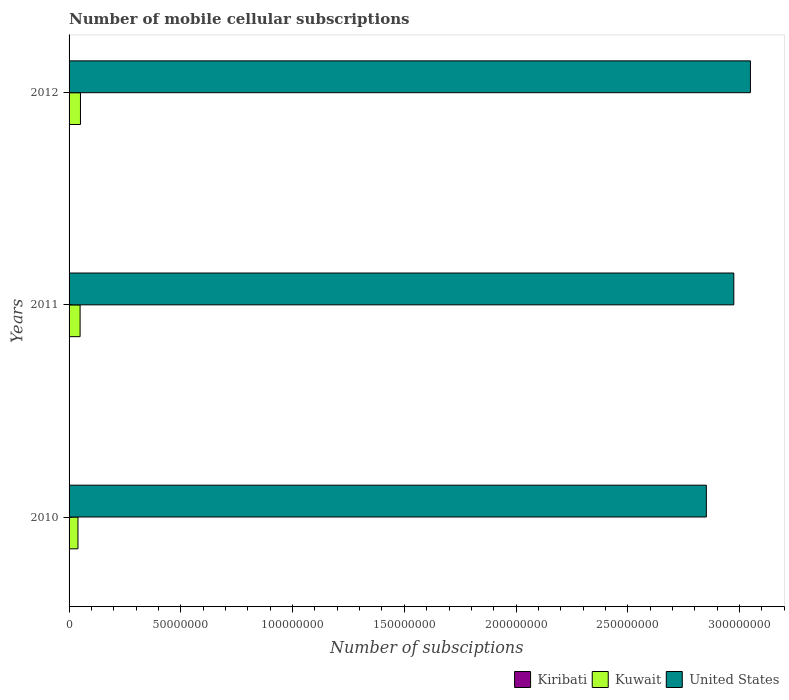How many different coloured bars are there?
Your answer should be compact. 3. How many groups of bars are there?
Your answer should be compact. 3. What is the label of the 3rd group of bars from the top?
Offer a terse response. 2010. What is the number of mobile cellular subscriptions in Kiribati in 2012?
Your answer should be very brief. 1.60e+04. Across all years, what is the maximum number of mobile cellular subscriptions in United States?
Offer a very short reply. 3.05e+08. Across all years, what is the minimum number of mobile cellular subscriptions in Kuwait?
Offer a very short reply. 3.98e+06. In which year was the number of mobile cellular subscriptions in Kuwait minimum?
Give a very brief answer. 2010. What is the total number of mobile cellular subscriptions in Kiribati in the graph?
Make the answer very short. 4.04e+04. What is the difference between the number of mobile cellular subscriptions in Kiribati in 2010 and that in 2012?
Keep it short and to the point. -5405. What is the difference between the number of mobile cellular subscriptions in United States in 2010 and the number of mobile cellular subscriptions in Kiribati in 2011?
Make the answer very short. 2.85e+08. What is the average number of mobile cellular subscriptions in United States per year?
Offer a terse response. 2.96e+08. In the year 2010, what is the difference between the number of mobile cellular subscriptions in Kuwait and number of mobile cellular subscriptions in United States?
Offer a terse response. -2.81e+08. In how many years, is the number of mobile cellular subscriptions in Kiribati greater than 110000000 ?
Provide a short and direct response. 0. What is the ratio of the number of mobile cellular subscriptions in United States in 2010 to that in 2011?
Keep it short and to the point. 0.96. Is the number of mobile cellular subscriptions in Kuwait in 2011 less than that in 2012?
Your answer should be compact. Yes. Is the difference between the number of mobile cellular subscriptions in Kuwait in 2010 and 2012 greater than the difference between the number of mobile cellular subscriptions in United States in 2010 and 2012?
Your answer should be compact. Yes. What is the difference between the highest and the second highest number of mobile cellular subscriptions in Kuwait?
Provide a short and direct response. 1.66e+05. What is the difference between the highest and the lowest number of mobile cellular subscriptions in United States?
Offer a terse response. 1.97e+07. In how many years, is the number of mobile cellular subscriptions in Kiribati greater than the average number of mobile cellular subscriptions in Kiribati taken over all years?
Your response must be concise. 2. What does the 1st bar from the top in 2010 represents?
Offer a terse response. United States. What does the 2nd bar from the bottom in 2012 represents?
Your response must be concise. Kuwait. What is the difference between two consecutive major ticks on the X-axis?
Offer a very short reply. 5.00e+07. Does the graph contain grids?
Keep it short and to the point. No. How are the legend labels stacked?
Your response must be concise. Horizontal. What is the title of the graph?
Your answer should be compact. Number of mobile cellular subscriptions. Does "Ireland" appear as one of the legend labels in the graph?
Make the answer very short. No. What is the label or title of the X-axis?
Make the answer very short. Number of subsciptions. What is the label or title of the Y-axis?
Keep it short and to the point. Years. What is the Number of subsciptions in Kiribati in 2010?
Ensure brevity in your answer.  1.06e+04. What is the Number of subsciptions in Kuwait in 2010?
Provide a succinct answer. 3.98e+06. What is the Number of subsciptions of United States in 2010?
Provide a short and direct response. 2.85e+08. What is the Number of subsciptions of Kiribati in 2011?
Offer a terse response. 1.38e+04. What is the Number of subsciptions in Kuwait in 2011?
Ensure brevity in your answer.  4.93e+06. What is the Number of subsciptions of United States in 2011?
Make the answer very short. 2.97e+08. What is the Number of subsciptions of Kiribati in 2012?
Offer a very short reply. 1.60e+04. What is the Number of subsciptions in Kuwait in 2012?
Keep it short and to the point. 5.10e+06. What is the Number of subsciptions in United States in 2012?
Keep it short and to the point. 3.05e+08. Across all years, what is the maximum Number of subsciptions of Kiribati?
Your answer should be very brief. 1.60e+04. Across all years, what is the maximum Number of subsciptions of Kuwait?
Your response must be concise. 5.10e+06. Across all years, what is the maximum Number of subsciptions in United States?
Your response must be concise. 3.05e+08. Across all years, what is the minimum Number of subsciptions in Kiribati?
Offer a very short reply. 1.06e+04. Across all years, what is the minimum Number of subsciptions of Kuwait?
Provide a succinct answer. 3.98e+06. Across all years, what is the minimum Number of subsciptions in United States?
Make the answer very short. 2.85e+08. What is the total Number of subsciptions of Kiribati in the graph?
Ensure brevity in your answer.  4.04e+04. What is the total Number of subsciptions of Kuwait in the graph?
Your answer should be compact. 1.40e+07. What is the total Number of subsciptions in United States in the graph?
Offer a terse response. 8.87e+08. What is the difference between the Number of subsciptions of Kiribati in 2010 and that in 2011?
Offer a terse response. -3193. What is the difference between the Number of subsciptions of Kuwait in 2010 and that in 2011?
Your answer should be compact. -9.55e+05. What is the difference between the Number of subsciptions of United States in 2010 and that in 2011?
Your answer should be compact. -1.23e+07. What is the difference between the Number of subsciptions in Kiribati in 2010 and that in 2012?
Ensure brevity in your answer.  -5405. What is the difference between the Number of subsciptions in Kuwait in 2010 and that in 2012?
Make the answer very short. -1.12e+06. What is the difference between the Number of subsciptions of United States in 2010 and that in 2012?
Keep it short and to the point. -1.97e+07. What is the difference between the Number of subsciptions in Kiribati in 2011 and that in 2012?
Provide a short and direct response. -2212. What is the difference between the Number of subsciptions in Kuwait in 2011 and that in 2012?
Ensure brevity in your answer.  -1.66e+05. What is the difference between the Number of subsciptions of United States in 2011 and that in 2012?
Ensure brevity in your answer.  -7.43e+06. What is the difference between the Number of subsciptions of Kiribati in 2010 and the Number of subsciptions of Kuwait in 2011?
Keep it short and to the point. -4.92e+06. What is the difference between the Number of subsciptions in Kiribati in 2010 and the Number of subsciptions in United States in 2011?
Give a very brief answer. -2.97e+08. What is the difference between the Number of subsciptions in Kuwait in 2010 and the Number of subsciptions in United States in 2011?
Provide a short and direct response. -2.93e+08. What is the difference between the Number of subsciptions of Kiribati in 2010 and the Number of subsciptions of Kuwait in 2012?
Make the answer very short. -5.09e+06. What is the difference between the Number of subsciptions in Kiribati in 2010 and the Number of subsciptions in United States in 2012?
Offer a terse response. -3.05e+08. What is the difference between the Number of subsciptions in Kuwait in 2010 and the Number of subsciptions in United States in 2012?
Your answer should be compact. -3.01e+08. What is the difference between the Number of subsciptions in Kiribati in 2011 and the Number of subsciptions in Kuwait in 2012?
Your answer should be very brief. -5.09e+06. What is the difference between the Number of subsciptions of Kiribati in 2011 and the Number of subsciptions of United States in 2012?
Your answer should be very brief. -3.05e+08. What is the difference between the Number of subsciptions in Kuwait in 2011 and the Number of subsciptions in United States in 2012?
Provide a short and direct response. -3.00e+08. What is the average Number of subsciptions in Kiribati per year?
Offer a terse response. 1.35e+04. What is the average Number of subsciptions of Kuwait per year?
Give a very brief answer. 4.67e+06. What is the average Number of subsciptions of United States per year?
Provide a succinct answer. 2.96e+08. In the year 2010, what is the difference between the Number of subsciptions in Kiribati and Number of subsciptions in Kuwait?
Provide a succinct answer. -3.97e+06. In the year 2010, what is the difference between the Number of subsciptions in Kiribati and Number of subsciptions in United States?
Give a very brief answer. -2.85e+08. In the year 2010, what is the difference between the Number of subsciptions in Kuwait and Number of subsciptions in United States?
Offer a terse response. -2.81e+08. In the year 2011, what is the difference between the Number of subsciptions in Kiribati and Number of subsciptions in Kuwait?
Keep it short and to the point. -4.92e+06. In the year 2011, what is the difference between the Number of subsciptions of Kiribati and Number of subsciptions of United States?
Your response must be concise. -2.97e+08. In the year 2011, what is the difference between the Number of subsciptions of Kuwait and Number of subsciptions of United States?
Offer a terse response. -2.92e+08. In the year 2012, what is the difference between the Number of subsciptions in Kiribati and Number of subsciptions in Kuwait?
Ensure brevity in your answer.  -5.08e+06. In the year 2012, what is the difference between the Number of subsciptions in Kiribati and Number of subsciptions in United States?
Your answer should be very brief. -3.05e+08. In the year 2012, what is the difference between the Number of subsciptions in Kuwait and Number of subsciptions in United States?
Your answer should be compact. -3.00e+08. What is the ratio of the Number of subsciptions of Kiribati in 2010 to that in 2011?
Provide a short and direct response. 0.77. What is the ratio of the Number of subsciptions in Kuwait in 2010 to that in 2011?
Provide a short and direct response. 0.81. What is the ratio of the Number of subsciptions in United States in 2010 to that in 2011?
Offer a very short reply. 0.96. What is the ratio of the Number of subsciptions in Kiribati in 2010 to that in 2012?
Offer a very short reply. 0.66. What is the ratio of the Number of subsciptions of Kuwait in 2010 to that in 2012?
Ensure brevity in your answer.  0.78. What is the ratio of the Number of subsciptions in United States in 2010 to that in 2012?
Your response must be concise. 0.94. What is the ratio of the Number of subsciptions in Kiribati in 2011 to that in 2012?
Make the answer very short. 0.86. What is the ratio of the Number of subsciptions of Kuwait in 2011 to that in 2012?
Keep it short and to the point. 0.97. What is the ratio of the Number of subsciptions of United States in 2011 to that in 2012?
Offer a terse response. 0.98. What is the difference between the highest and the second highest Number of subsciptions of Kiribati?
Make the answer very short. 2212. What is the difference between the highest and the second highest Number of subsciptions of Kuwait?
Keep it short and to the point. 1.66e+05. What is the difference between the highest and the second highest Number of subsciptions of United States?
Provide a succinct answer. 7.43e+06. What is the difference between the highest and the lowest Number of subsciptions of Kiribati?
Make the answer very short. 5405. What is the difference between the highest and the lowest Number of subsciptions of Kuwait?
Offer a terse response. 1.12e+06. What is the difference between the highest and the lowest Number of subsciptions of United States?
Keep it short and to the point. 1.97e+07. 